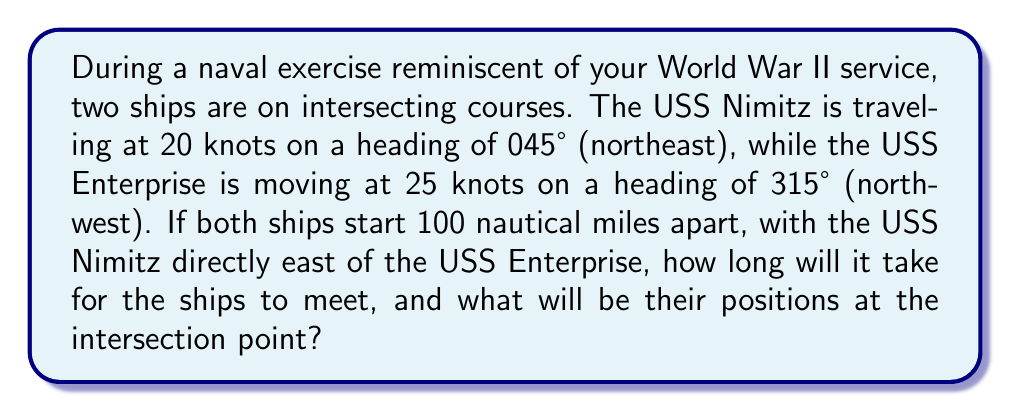Provide a solution to this math problem. Let's approach this problem step by step:

1) First, we need to set up a coordinate system. Let's place the USS Enterprise at the origin (0, 0) and the USS Nimitz at (100, 0).

2) We can break down the ships' velocities into x and y components:

   USS Nimitz: 
   $$v_{x1} = 20 \cos(45°) = 20 \cdot \frac{\sqrt{2}}{2} \approx 14.14 \text{ knots}$$
   $$v_{y1} = 20 \sin(45°) = 20 \cdot \frac{\sqrt{2}}{2} \approx 14.14 \text{ knots}$$

   USS Enterprise:
   $$v_{x2} = 25 \cos(315°) = -25 \cdot \frac{\sqrt{2}}{2} \approx -17.68 \text{ knots}$$
   $$v_{y2} = 25 \sin(315°) = 25 \cdot \frac{\sqrt{2}}{2} \approx 17.68 \text{ knots}$$

3) The position of each ship after time t can be expressed as:

   USS Nimitz: $$(100 + 14.14t, 14.14t)$$
   USS Enterprise: $$(-17.68t, 17.68t)$$

4) At the intersection point, these positions will be equal:

   $$100 + 14.14t = -17.68t$$
   $$14.14t = 17.68t$$

5) Solving these equations:

   From the first equation: $$100 = -31.82t$$ $$t \approx 3.14 \text{ hours}$$

6) To find the intersection point, we can substitute this time into either ship's position equation:

   $$x = 100 + 14.14(3.14) \approx 144.4 \text{ nautical miles}$$
   $$y = 14.14(3.14) \approx 44.4 \text{ nautical miles}$$

Therefore, the ships will meet after approximately 3.14 hours at the point (144.4, 44.4) nautical miles from the starting position of the USS Enterprise.
Answer: The ships will intersect after approximately 3.14 hours at the point (144.4, 44.4) nautical miles from the USS Enterprise's starting position. 